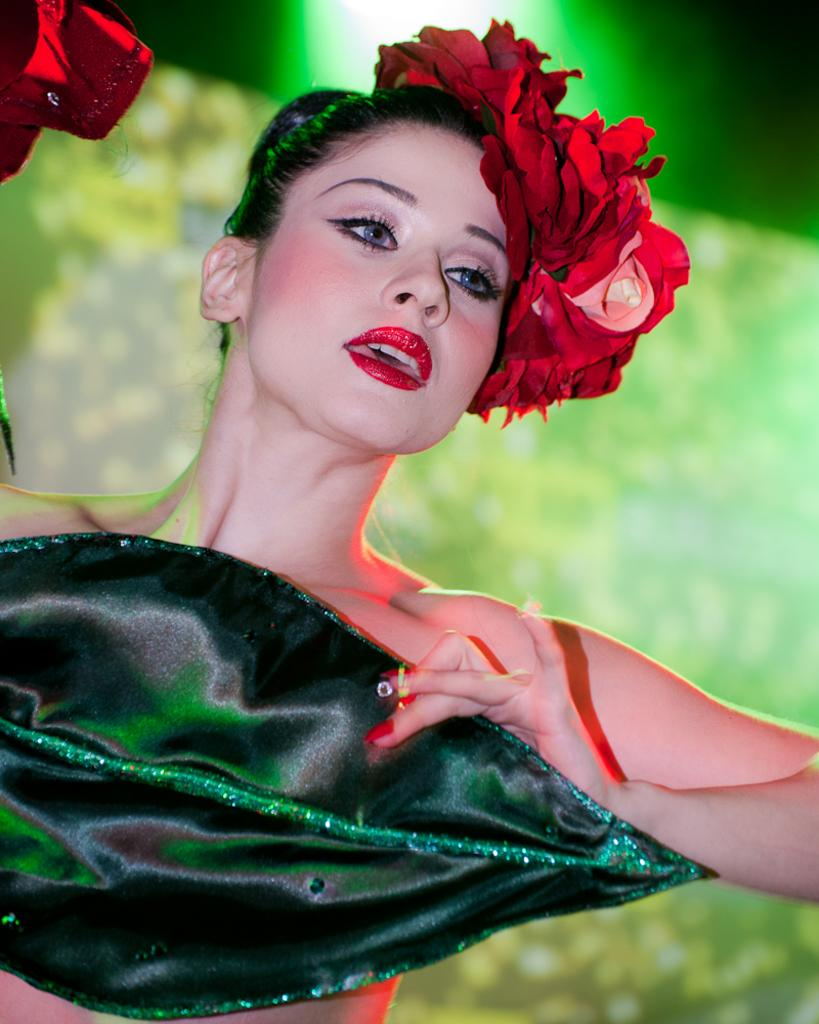Who is the main subject in the image? There is a girl in the image. What is the girl wearing? The girl is wearing different costumes. Can you describe the background of the image? The background of the image is blurred. What type of crook can be seen in the girl's hand in the image? There is no crook present in the image; the girl is wearing different costumes, but no crook is visible. 